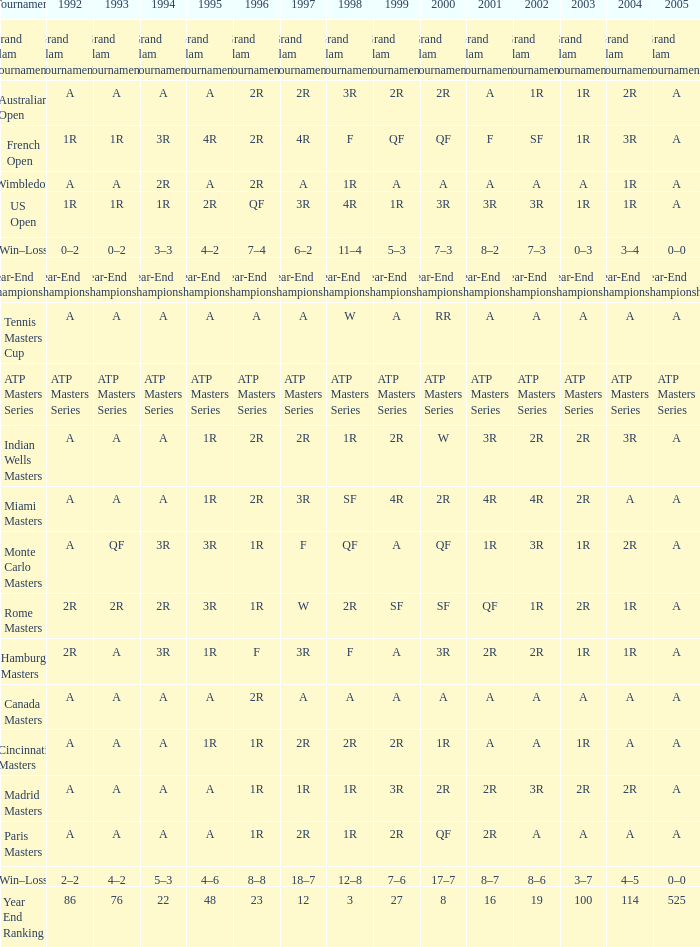What is Tournament, when 2000 is "A"? Wimbledon, Canada Masters. 